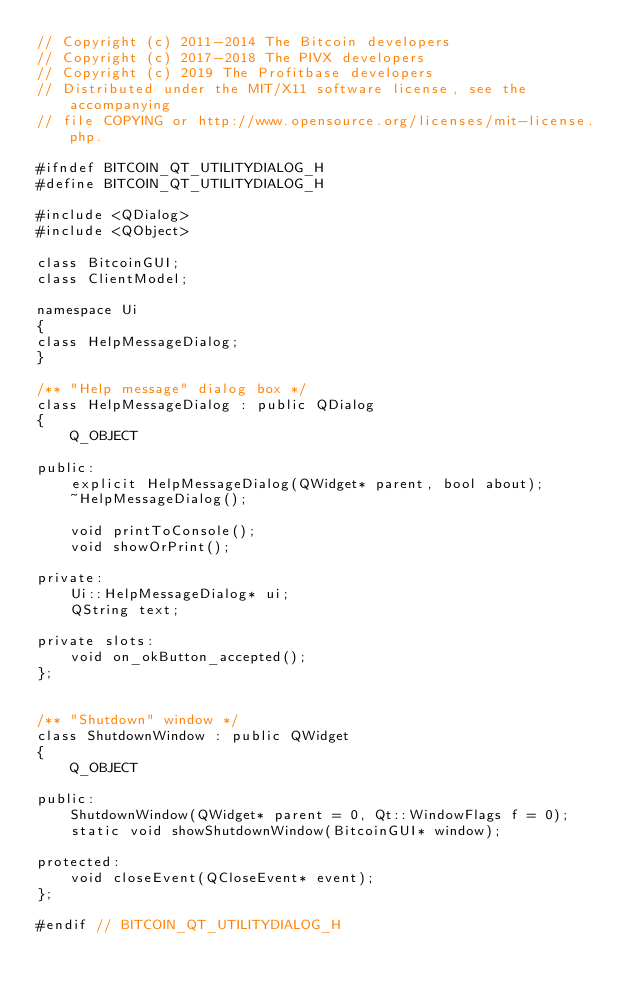<code> <loc_0><loc_0><loc_500><loc_500><_C_>// Copyright (c) 2011-2014 The Bitcoin developers
// Copyright (c) 2017-2018 The PIVX developers
// Copyright (c) 2019 The Profitbase developers
// Distributed under the MIT/X11 software license, see the accompanying
// file COPYING or http://www.opensource.org/licenses/mit-license.php.

#ifndef BITCOIN_QT_UTILITYDIALOG_H
#define BITCOIN_QT_UTILITYDIALOG_H

#include <QDialog>
#include <QObject>

class BitcoinGUI;
class ClientModel;

namespace Ui
{
class HelpMessageDialog;
}

/** "Help message" dialog box */
class HelpMessageDialog : public QDialog
{
    Q_OBJECT

public:
    explicit HelpMessageDialog(QWidget* parent, bool about);
    ~HelpMessageDialog();

    void printToConsole();
    void showOrPrint();

private:
    Ui::HelpMessageDialog* ui;
    QString text;

private slots:
    void on_okButton_accepted();
};


/** "Shutdown" window */
class ShutdownWindow : public QWidget
{
    Q_OBJECT

public:
    ShutdownWindow(QWidget* parent = 0, Qt::WindowFlags f = 0);
    static void showShutdownWindow(BitcoinGUI* window);

protected:
    void closeEvent(QCloseEvent* event);
};

#endif // BITCOIN_QT_UTILITYDIALOG_H
</code> 